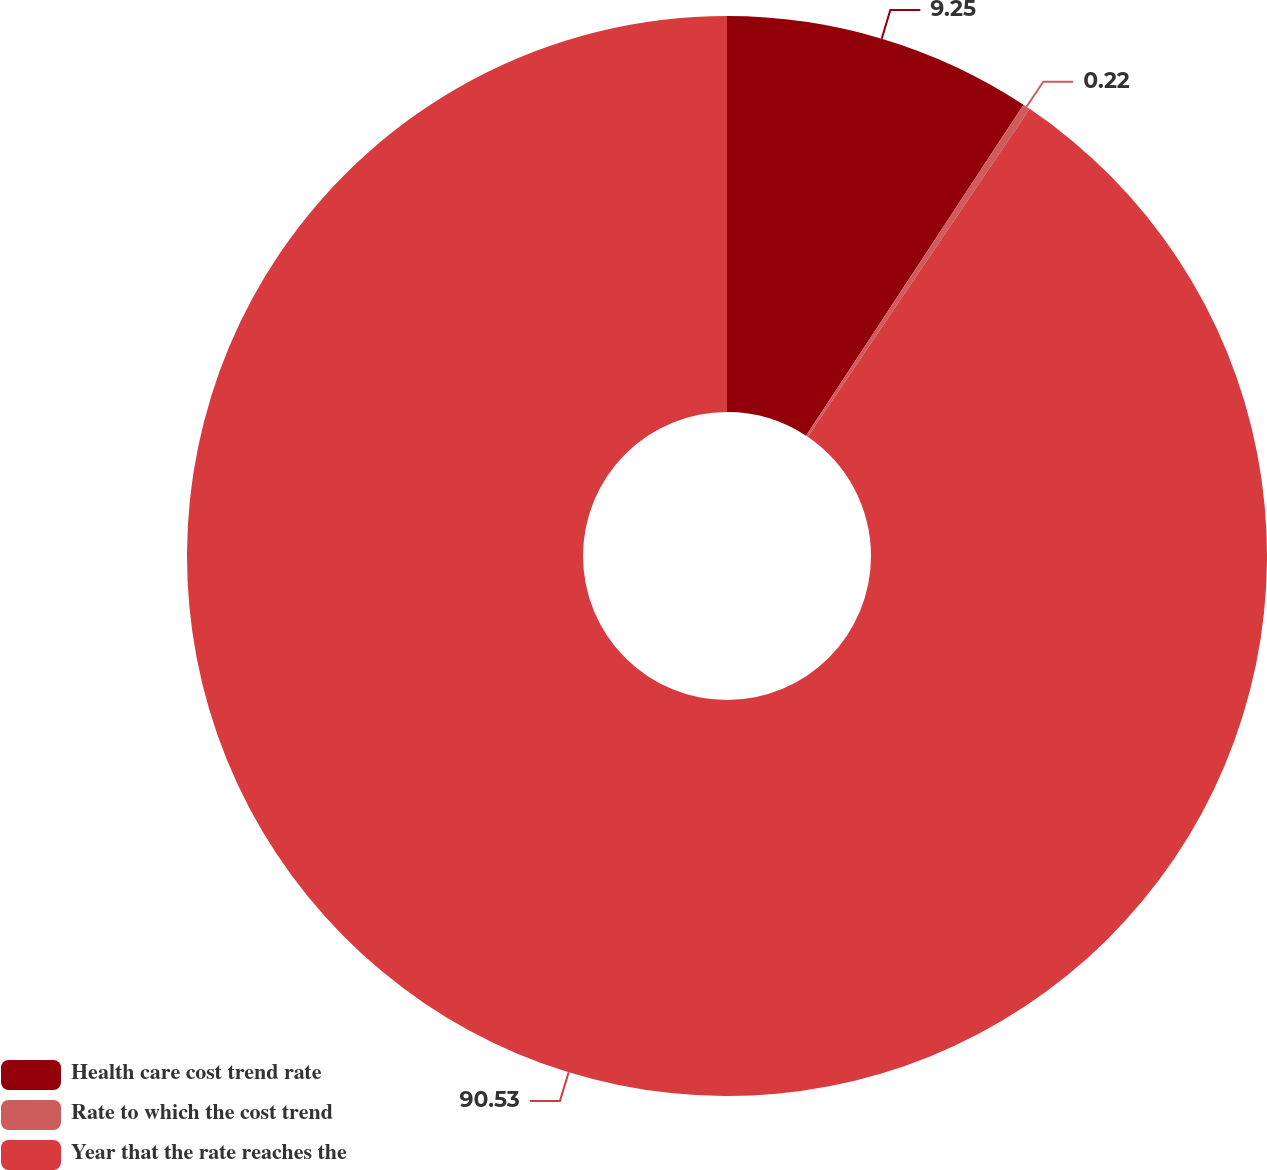Convert chart. <chart><loc_0><loc_0><loc_500><loc_500><pie_chart><fcel>Health care cost trend rate<fcel>Rate to which the cost trend<fcel>Year that the rate reaches the<nl><fcel>9.25%<fcel>0.22%<fcel>90.52%<nl></chart> 